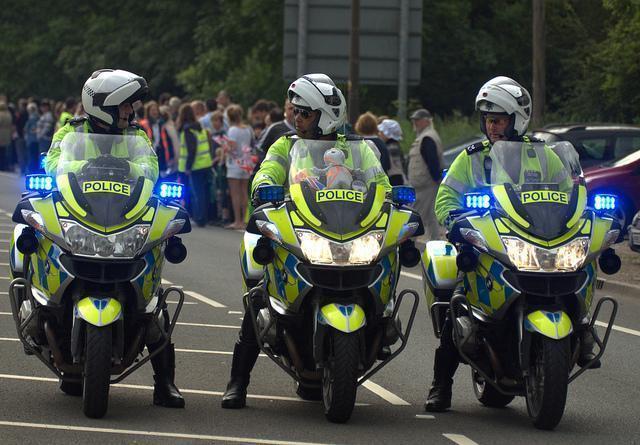Why are the bike riders wearing yellow?
Select the correct answer and articulate reasoning with the following format: 'Answer: answer
Rationale: rationale.'
Options: As prank, style, visibility, camouflage. Answer: visibility.
Rationale: They want visibility. 